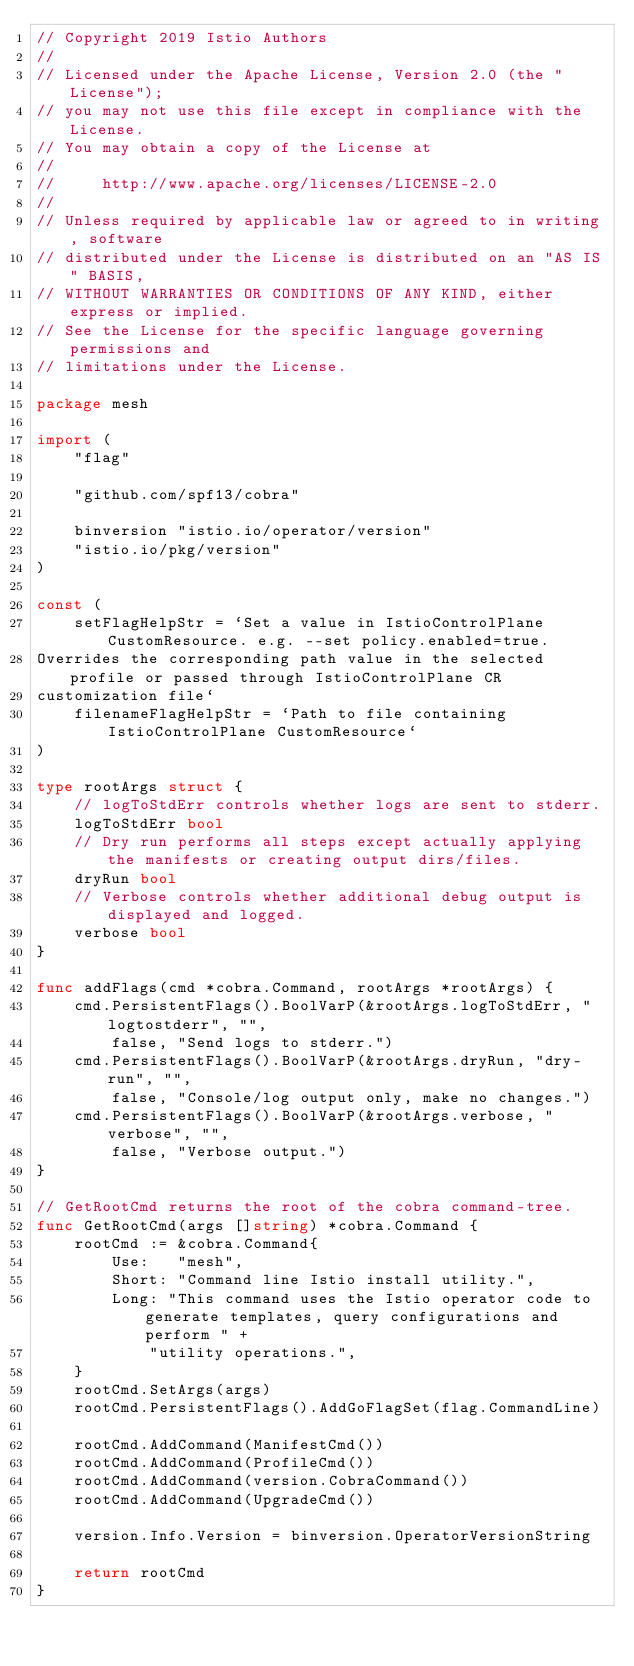Convert code to text. <code><loc_0><loc_0><loc_500><loc_500><_Go_>// Copyright 2019 Istio Authors
//
// Licensed under the Apache License, Version 2.0 (the "License");
// you may not use this file except in compliance with the License.
// You may obtain a copy of the License at
//
//     http://www.apache.org/licenses/LICENSE-2.0
//
// Unless required by applicable law or agreed to in writing, software
// distributed under the License is distributed on an "AS IS" BASIS,
// WITHOUT WARRANTIES OR CONDITIONS OF ANY KIND, either express or implied.
// See the License for the specific language governing permissions and
// limitations under the License.

package mesh

import (
	"flag"

	"github.com/spf13/cobra"

	binversion "istio.io/operator/version"
	"istio.io/pkg/version"
)

const (
	setFlagHelpStr = `Set a value in IstioControlPlane CustomResource. e.g. --set policy.enabled=true.
Overrides the corresponding path value in the selected profile or passed through IstioControlPlane CR
customization file`
	filenameFlagHelpStr = `Path to file containing IstioControlPlane CustomResource`
)

type rootArgs struct {
	// logToStdErr controls whether logs are sent to stderr.
	logToStdErr bool
	// Dry run performs all steps except actually applying the manifests or creating output dirs/files.
	dryRun bool
	// Verbose controls whether additional debug output is displayed and logged.
	verbose bool
}

func addFlags(cmd *cobra.Command, rootArgs *rootArgs) {
	cmd.PersistentFlags().BoolVarP(&rootArgs.logToStdErr, "logtostderr", "",
		false, "Send logs to stderr.")
	cmd.PersistentFlags().BoolVarP(&rootArgs.dryRun, "dry-run", "",
		false, "Console/log output only, make no changes.")
	cmd.PersistentFlags().BoolVarP(&rootArgs.verbose, "verbose", "",
		false, "Verbose output.")
}

// GetRootCmd returns the root of the cobra command-tree.
func GetRootCmd(args []string) *cobra.Command {
	rootCmd := &cobra.Command{
		Use:   "mesh",
		Short: "Command line Istio install utility.",
		Long: "This command uses the Istio operator code to generate templates, query configurations and perform " +
			"utility operations.",
	}
	rootCmd.SetArgs(args)
	rootCmd.PersistentFlags().AddGoFlagSet(flag.CommandLine)

	rootCmd.AddCommand(ManifestCmd())
	rootCmd.AddCommand(ProfileCmd())
	rootCmd.AddCommand(version.CobraCommand())
	rootCmd.AddCommand(UpgradeCmd())

	version.Info.Version = binversion.OperatorVersionString

	return rootCmd
}
</code> 